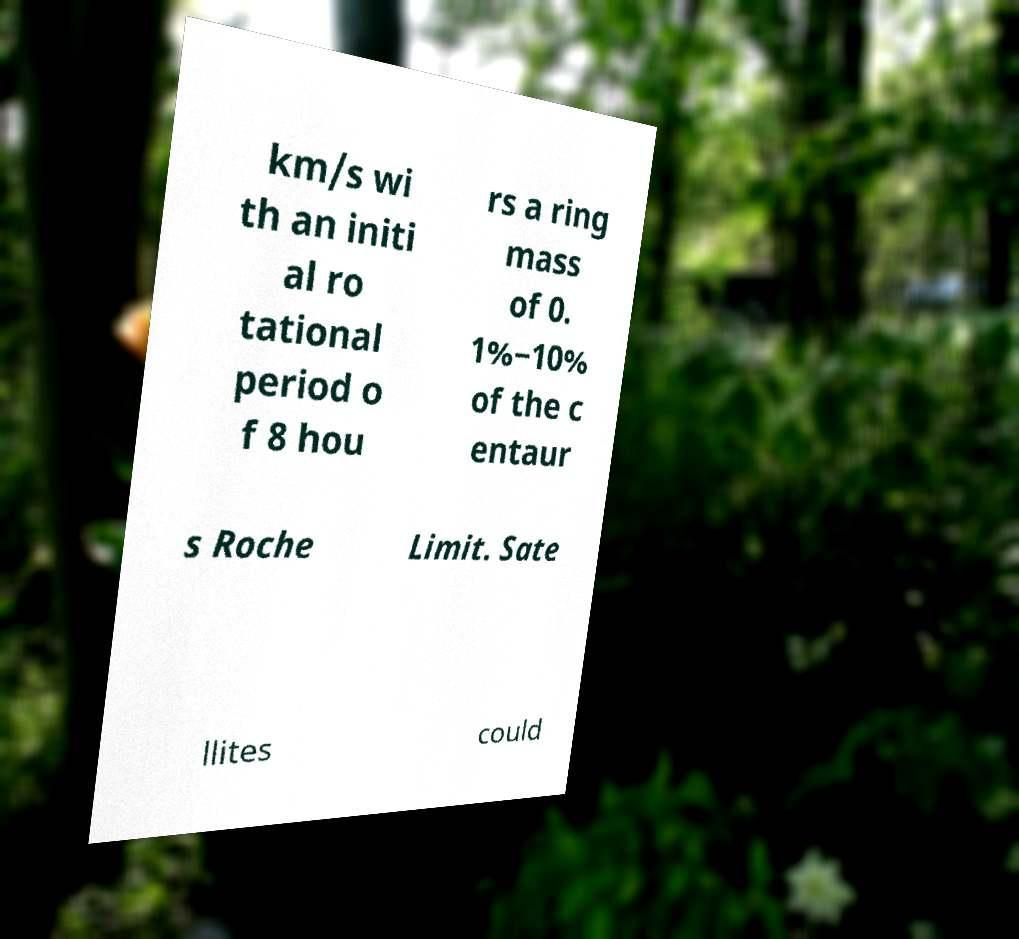Could you assist in decoding the text presented in this image and type it out clearly? km/s wi th an initi al ro tational period o f 8 hou rs a ring mass of 0. 1%−10% of the c entaur s Roche Limit. Sate llites could 